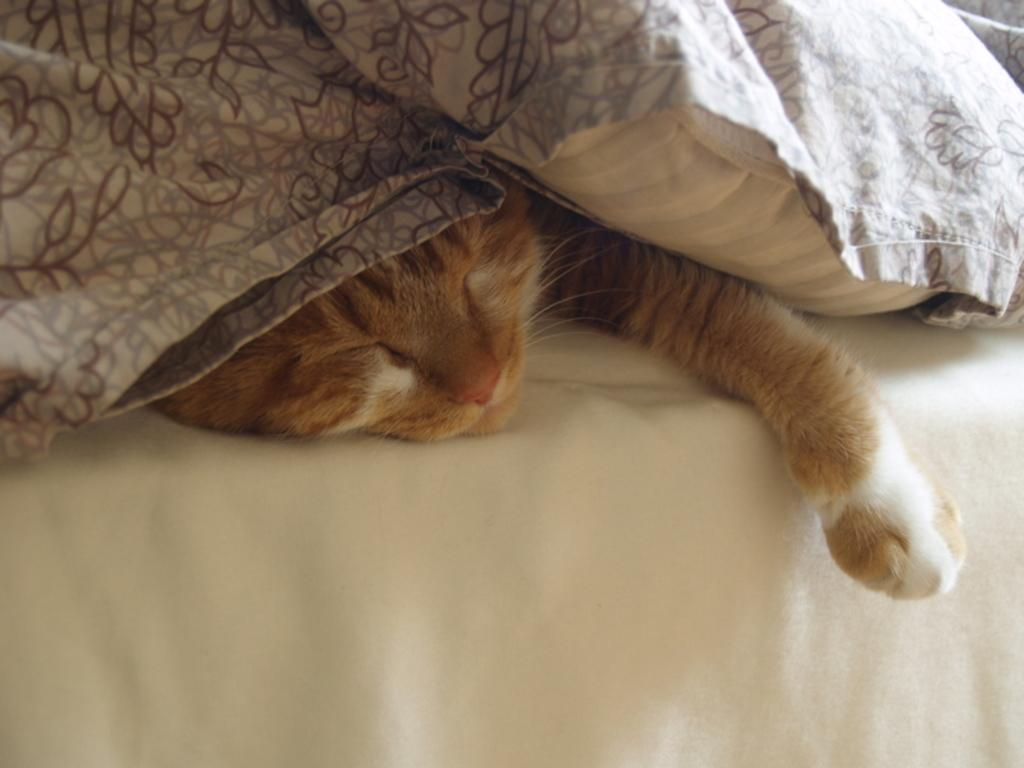What type of animal is in the picture? There is a cat in the picture. What is the cat doing in the picture? The cat is sleeping in the picture. Where is the cat located in the picture? The cat is on a bed in the picture. What is the cat resting beneath in the picture? The cat is beneath a pillow in the picture. What type of bedding is present on the bed? There is a blanket on the bed in the picture. What type of needle is the cat using to sew in the picture? There is no needle present in the image, and the cat is not sewing; it is sleeping. 